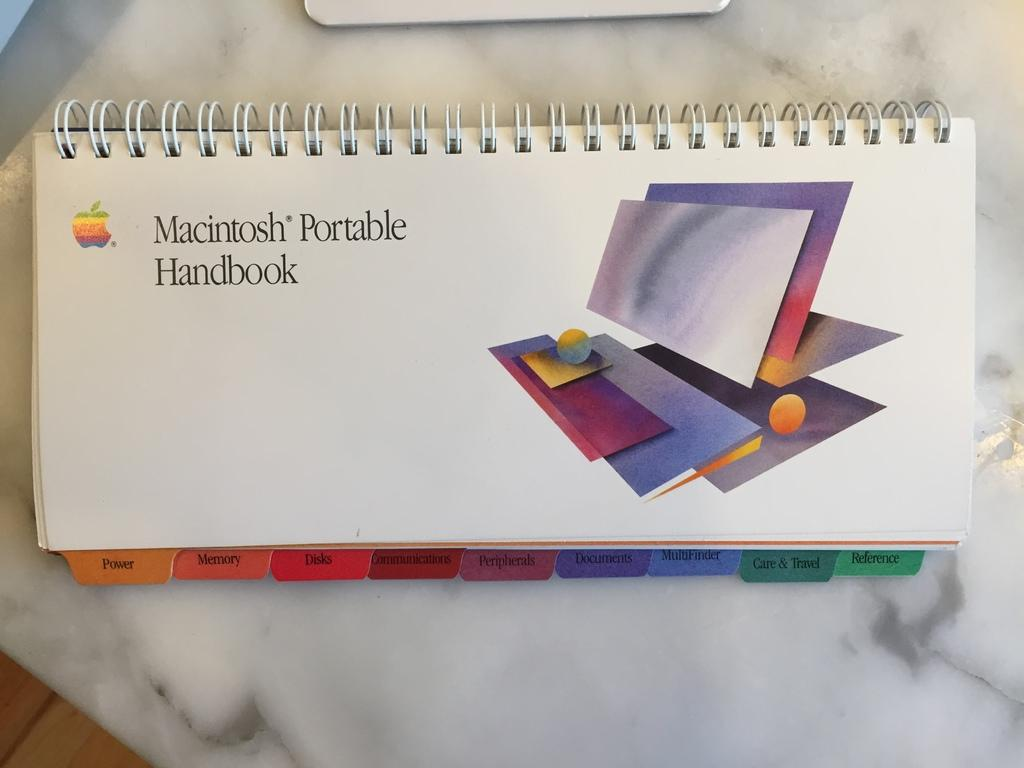<image>
Relay a brief, clear account of the picture shown. A spiral bound handbook for the Macintosh Portable product. 